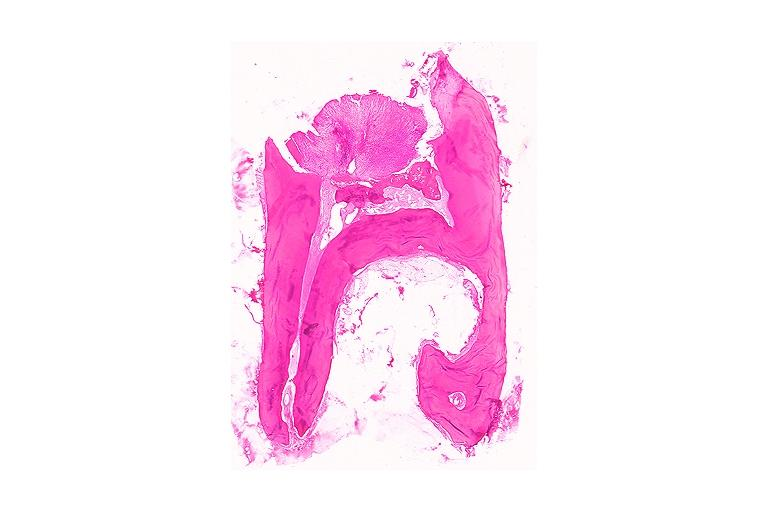does this image show chronic hyperplastic pulpitis?
Answer the question using a single word or phrase. Yes 